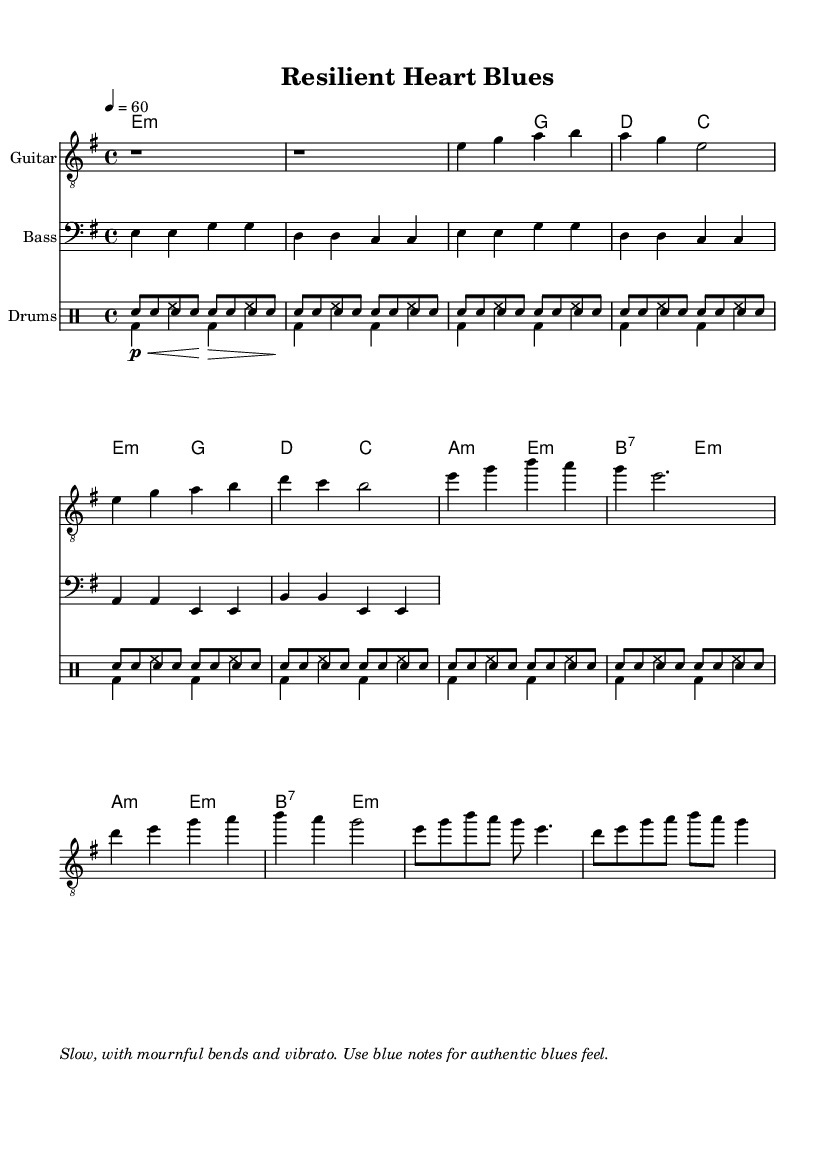What is the key signature of this music? The key signature is indicated at the beginning of the score, where it shows one flat. This means it is in E minor, which is the relative minor to G major.
Answer: E minor What is the time signature of the piece? The time signature is found immediately after the key signature. It shows a 4 over 4, meaning there are four beats in a measure, and a quarter note receives one beat.
Answer: 4/4 What is the tempo marking of this piece? The tempo marking is found in the global section of the score, which states "4 = 60". This indicates the number of beats per minute.
Answer: 60 What chords are used in the chorus? The chorus contains chords listed in the chord mode section. They are A minor, E minor, B7, and E minor.
Answer: A minor, E minor, B7 How many measures are in the verse? To find this, we look at the verse section under the guitar music and count the measures from the notation. There are four measures in total for the verse.
Answer: 4 What is the primary rhythmic feature of the drum pattern? The drum pattern is indicated by the drummode section and shows a combination of snare hits and bass drum hits woven into a repeating pattern, typical for blues rhythm.
Answer: Snare and bass What is the style indication for the guitar performance? The style indication is towards the end of the score where it suggests the guitar style; it mentions to use "blue notes" and techniques like "bends and vibrato" for an authentic blues feel.
Answer: Blue notes 